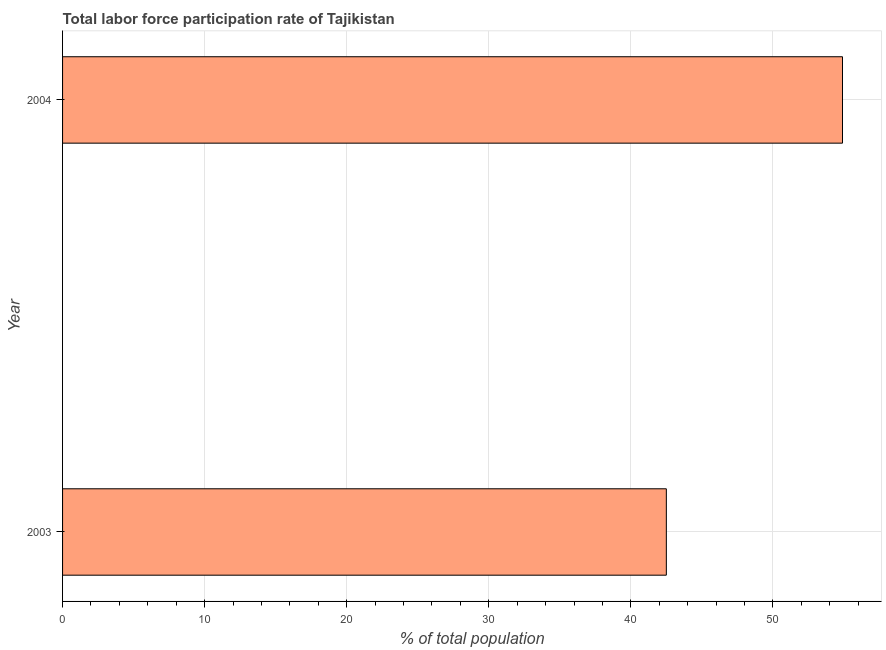Does the graph contain any zero values?
Your response must be concise. No. What is the title of the graph?
Your response must be concise. Total labor force participation rate of Tajikistan. What is the label or title of the X-axis?
Provide a short and direct response. % of total population. What is the label or title of the Y-axis?
Provide a short and direct response. Year. What is the total labor force participation rate in 2003?
Ensure brevity in your answer.  42.5. Across all years, what is the maximum total labor force participation rate?
Give a very brief answer. 54.9. Across all years, what is the minimum total labor force participation rate?
Your answer should be compact. 42.5. In which year was the total labor force participation rate maximum?
Make the answer very short. 2004. In which year was the total labor force participation rate minimum?
Provide a short and direct response. 2003. What is the sum of the total labor force participation rate?
Make the answer very short. 97.4. What is the difference between the total labor force participation rate in 2003 and 2004?
Your response must be concise. -12.4. What is the average total labor force participation rate per year?
Keep it short and to the point. 48.7. What is the median total labor force participation rate?
Your response must be concise. 48.7. Do a majority of the years between 2003 and 2004 (inclusive) have total labor force participation rate greater than 20 %?
Provide a short and direct response. Yes. What is the ratio of the total labor force participation rate in 2003 to that in 2004?
Make the answer very short. 0.77. Is the total labor force participation rate in 2003 less than that in 2004?
Keep it short and to the point. Yes. Are the values on the major ticks of X-axis written in scientific E-notation?
Offer a terse response. No. What is the % of total population in 2003?
Provide a succinct answer. 42.5. What is the % of total population of 2004?
Your response must be concise. 54.9. What is the difference between the % of total population in 2003 and 2004?
Your response must be concise. -12.4. What is the ratio of the % of total population in 2003 to that in 2004?
Give a very brief answer. 0.77. 